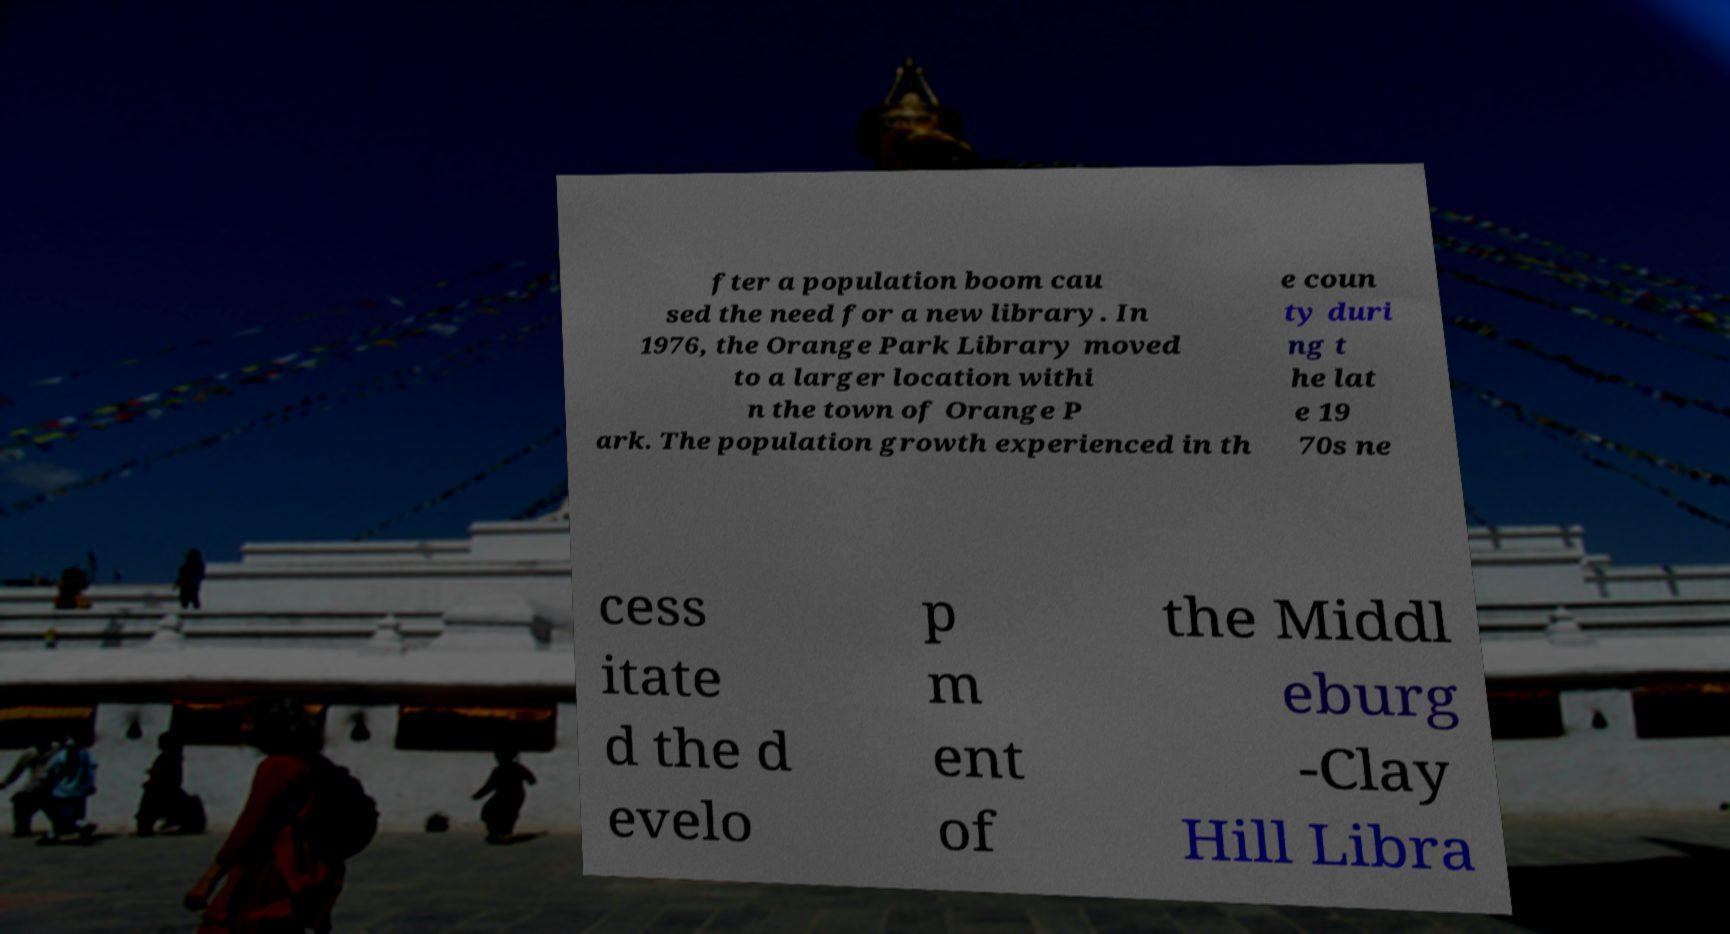Please read and relay the text visible in this image. What does it say? fter a population boom cau sed the need for a new library. In 1976, the Orange Park Library moved to a larger location withi n the town of Orange P ark. The population growth experienced in th e coun ty duri ng t he lat e 19 70s ne cess itate d the d evelo p m ent of the Middl eburg -Clay Hill Libra 